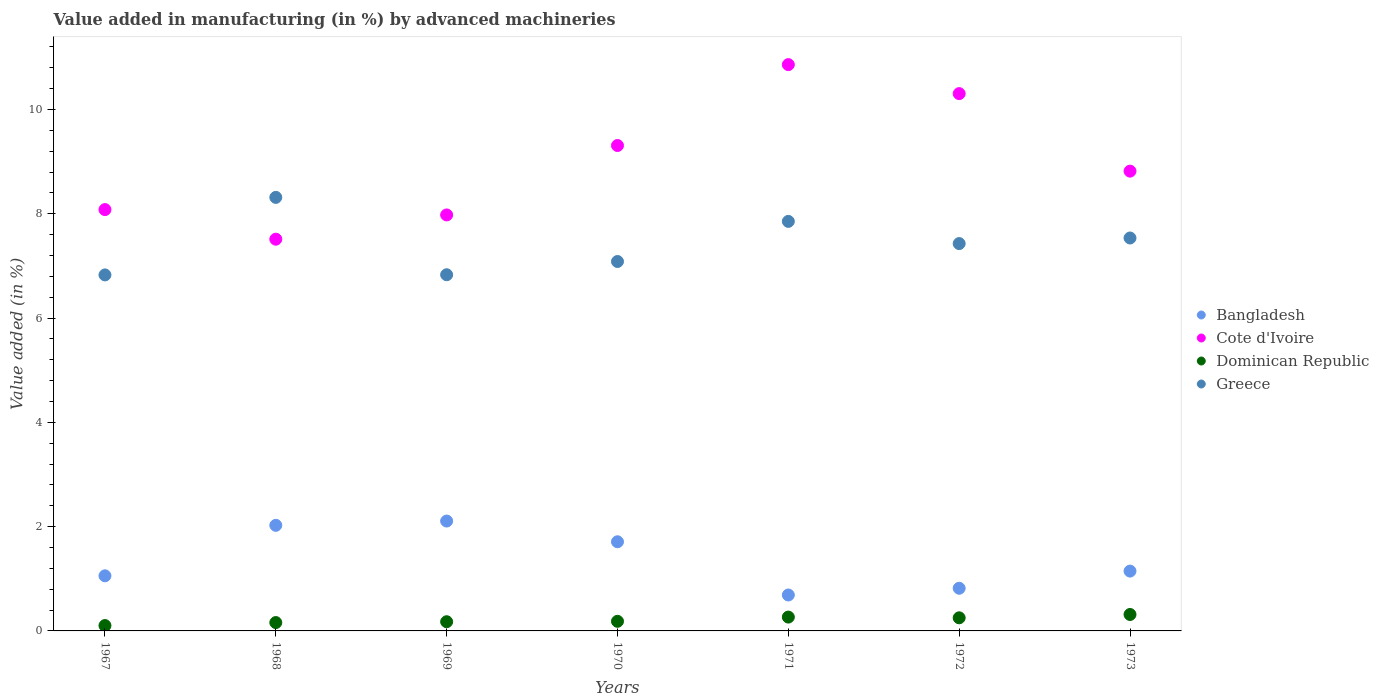Is the number of dotlines equal to the number of legend labels?
Your answer should be very brief. Yes. What is the percentage of value added in manufacturing by advanced machineries in Cote d'Ivoire in 1968?
Your answer should be compact. 7.51. Across all years, what is the maximum percentage of value added in manufacturing by advanced machineries in Cote d'Ivoire?
Give a very brief answer. 10.86. Across all years, what is the minimum percentage of value added in manufacturing by advanced machineries in Bangladesh?
Your response must be concise. 0.69. In which year was the percentage of value added in manufacturing by advanced machineries in Bangladesh maximum?
Give a very brief answer. 1969. In which year was the percentage of value added in manufacturing by advanced machineries in Greece minimum?
Offer a terse response. 1967. What is the total percentage of value added in manufacturing by advanced machineries in Bangladesh in the graph?
Provide a succinct answer. 9.55. What is the difference between the percentage of value added in manufacturing by advanced machineries in Bangladesh in 1967 and that in 1972?
Give a very brief answer. 0.24. What is the difference between the percentage of value added in manufacturing by advanced machineries in Bangladesh in 1969 and the percentage of value added in manufacturing by advanced machineries in Dominican Republic in 1970?
Provide a succinct answer. 1.92. What is the average percentage of value added in manufacturing by advanced machineries in Cote d'Ivoire per year?
Your answer should be very brief. 8.98. In the year 1969, what is the difference between the percentage of value added in manufacturing by advanced machineries in Cote d'Ivoire and percentage of value added in manufacturing by advanced machineries in Greece?
Give a very brief answer. 1.15. In how many years, is the percentage of value added in manufacturing by advanced machineries in Cote d'Ivoire greater than 7.2 %?
Ensure brevity in your answer.  7. What is the ratio of the percentage of value added in manufacturing by advanced machineries in Bangladesh in 1968 to that in 1969?
Give a very brief answer. 0.96. Is the percentage of value added in manufacturing by advanced machineries in Cote d'Ivoire in 1968 less than that in 1972?
Keep it short and to the point. Yes. What is the difference between the highest and the second highest percentage of value added in manufacturing by advanced machineries in Cote d'Ivoire?
Your answer should be very brief. 0.56. What is the difference between the highest and the lowest percentage of value added in manufacturing by advanced machineries in Greece?
Provide a short and direct response. 1.49. Is the sum of the percentage of value added in manufacturing by advanced machineries in Greece in 1972 and 1973 greater than the maximum percentage of value added in manufacturing by advanced machineries in Bangladesh across all years?
Give a very brief answer. Yes. Is it the case that in every year, the sum of the percentage of value added in manufacturing by advanced machineries in Cote d'Ivoire and percentage of value added in manufacturing by advanced machineries in Greece  is greater than the sum of percentage of value added in manufacturing by advanced machineries in Bangladesh and percentage of value added in manufacturing by advanced machineries in Dominican Republic?
Offer a very short reply. Yes. Is it the case that in every year, the sum of the percentage of value added in manufacturing by advanced machineries in Cote d'Ivoire and percentage of value added in manufacturing by advanced machineries in Greece  is greater than the percentage of value added in manufacturing by advanced machineries in Bangladesh?
Keep it short and to the point. Yes. Does the percentage of value added in manufacturing by advanced machineries in Cote d'Ivoire monotonically increase over the years?
Provide a short and direct response. No. Is the percentage of value added in manufacturing by advanced machineries in Greece strictly greater than the percentage of value added in manufacturing by advanced machineries in Bangladesh over the years?
Your answer should be very brief. Yes. Is the percentage of value added in manufacturing by advanced machineries in Greece strictly less than the percentage of value added in manufacturing by advanced machineries in Cote d'Ivoire over the years?
Provide a succinct answer. No. How many years are there in the graph?
Offer a very short reply. 7. What is the difference between two consecutive major ticks on the Y-axis?
Ensure brevity in your answer.  2. Does the graph contain any zero values?
Offer a very short reply. No. Does the graph contain grids?
Provide a succinct answer. No. What is the title of the graph?
Offer a very short reply. Value added in manufacturing (in %) by advanced machineries. What is the label or title of the X-axis?
Your answer should be compact. Years. What is the label or title of the Y-axis?
Your answer should be compact. Value added (in %). What is the Value added (in %) in Bangladesh in 1967?
Your response must be concise. 1.06. What is the Value added (in %) of Cote d'Ivoire in 1967?
Your response must be concise. 8.08. What is the Value added (in %) of Dominican Republic in 1967?
Offer a terse response. 0.1. What is the Value added (in %) of Greece in 1967?
Provide a short and direct response. 6.83. What is the Value added (in %) in Bangladesh in 1968?
Ensure brevity in your answer.  2.03. What is the Value added (in %) of Cote d'Ivoire in 1968?
Provide a succinct answer. 7.51. What is the Value added (in %) in Dominican Republic in 1968?
Your answer should be very brief. 0.16. What is the Value added (in %) in Greece in 1968?
Offer a terse response. 8.31. What is the Value added (in %) of Bangladesh in 1969?
Provide a short and direct response. 2.11. What is the Value added (in %) of Cote d'Ivoire in 1969?
Make the answer very short. 7.98. What is the Value added (in %) of Dominican Republic in 1969?
Offer a very short reply. 0.18. What is the Value added (in %) of Greece in 1969?
Make the answer very short. 6.83. What is the Value added (in %) in Bangladesh in 1970?
Your answer should be compact. 1.71. What is the Value added (in %) of Cote d'Ivoire in 1970?
Your answer should be compact. 9.31. What is the Value added (in %) of Dominican Republic in 1970?
Make the answer very short. 0.18. What is the Value added (in %) in Greece in 1970?
Keep it short and to the point. 7.08. What is the Value added (in %) of Bangladesh in 1971?
Ensure brevity in your answer.  0.69. What is the Value added (in %) in Cote d'Ivoire in 1971?
Your answer should be very brief. 10.86. What is the Value added (in %) in Dominican Republic in 1971?
Keep it short and to the point. 0.27. What is the Value added (in %) in Greece in 1971?
Keep it short and to the point. 7.85. What is the Value added (in %) in Bangladesh in 1972?
Provide a short and direct response. 0.82. What is the Value added (in %) in Cote d'Ivoire in 1972?
Your answer should be compact. 10.3. What is the Value added (in %) of Dominican Republic in 1972?
Your response must be concise. 0.25. What is the Value added (in %) of Greece in 1972?
Offer a terse response. 7.43. What is the Value added (in %) of Bangladesh in 1973?
Offer a terse response. 1.15. What is the Value added (in %) of Cote d'Ivoire in 1973?
Your answer should be very brief. 8.82. What is the Value added (in %) in Dominican Republic in 1973?
Make the answer very short. 0.32. What is the Value added (in %) in Greece in 1973?
Ensure brevity in your answer.  7.54. Across all years, what is the maximum Value added (in %) in Bangladesh?
Provide a succinct answer. 2.11. Across all years, what is the maximum Value added (in %) of Cote d'Ivoire?
Your answer should be very brief. 10.86. Across all years, what is the maximum Value added (in %) of Dominican Republic?
Provide a succinct answer. 0.32. Across all years, what is the maximum Value added (in %) in Greece?
Your answer should be compact. 8.31. Across all years, what is the minimum Value added (in %) of Bangladesh?
Keep it short and to the point. 0.69. Across all years, what is the minimum Value added (in %) of Cote d'Ivoire?
Ensure brevity in your answer.  7.51. Across all years, what is the minimum Value added (in %) in Dominican Republic?
Give a very brief answer. 0.1. Across all years, what is the minimum Value added (in %) of Greece?
Provide a short and direct response. 6.83. What is the total Value added (in %) of Bangladesh in the graph?
Give a very brief answer. 9.55. What is the total Value added (in %) in Cote d'Ivoire in the graph?
Give a very brief answer. 62.86. What is the total Value added (in %) in Dominican Republic in the graph?
Ensure brevity in your answer.  1.46. What is the total Value added (in %) of Greece in the graph?
Give a very brief answer. 51.88. What is the difference between the Value added (in %) in Bangladesh in 1967 and that in 1968?
Your answer should be very brief. -0.97. What is the difference between the Value added (in %) in Cote d'Ivoire in 1967 and that in 1968?
Give a very brief answer. 0.57. What is the difference between the Value added (in %) of Dominican Republic in 1967 and that in 1968?
Make the answer very short. -0.06. What is the difference between the Value added (in %) in Greece in 1967 and that in 1968?
Offer a terse response. -1.49. What is the difference between the Value added (in %) in Bangladesh in 1967 and that in 1969?
Provide a short and direct response. -1.05. What is the difference between the Value added (in %) of Cote d'Ivoire in 1967 and that in 1969?
Keep it short and to the point. 0.1. What is the difference between the Value added (in %) of Dominican Republic in 1967 and that in 1969?
Ensure brevity in your answer.  -0.07. What is the difference between the Value added (in %) in Greece in 1967 and that in 1969?
Give a very brief answer. -0. What is the difference between the Value added (in %) in Bangladesh in 1967 and that in 1970?
Make the answer very short. -0.65. What is the difference between the Value added (in %) in Cote d'Ivoire in 1967 and that in 1970?
Ensure brevity in your answer.  -1.23. What is the difference between the Value added (in %) of Dominican Republic in 1967 and that in 1970?
Your response must be concise. -0.08. What is the difference between the Value added (in %) in Greece in 1967 and that in 1970?
Give a very brief answer. -0.26. What is the difference between the Value added (in %) in Bangladesh in 1967 and that in 1971?
Your answer should be very brief. 0.37. What is the difference between the Value added (in %) in Cote d'Ivoire in 1967 and that in 1971?
Your answer should be compact. -2.78. What is the difference between the Value added (in %) in Dominican Republic in 1967 and that in 1971?
Provide a succinct answer. -0.16. What is the difference between the Value added (in %) in Greece in 1967 and that in 1971?
Your answer should be very brief. -1.03. What is the difference between the Value added (in %) in Bangladesh in 1967 and that in 1972?
Ensure brevity in your answer.  0.24. What is the difference between the Value added (in %) of Cote d'Ivoire in 1967 and that in 1972?
Your answer should be very brief. -2.22. What is the difference between the Value added (in %) of Dominican Republic in 1967 and that in 1972?
Offer a terse response. -0.15. What is the difference between the Value added (in %) of Greece in 1967 and that in 1972?
Give a very brief answer. -0.6. What is the difference between the Value added (in %) of Bangladesh in 1967 and that in 1973?
Your answer should be compact. -0.09. What is the difference between the Value added (in %) in Cote d'Ivoire in 1967 and that in 1973?
Provide a short and direct response. -0.74. What is the difference between the Value added (in %) in Dominican Republic in 1967 and that in 1973?
Provide a succinct answer. -0.21. What is the difference between the Value added (in %) in Greece in 1967 and that in 1973?
Give a very brief answer. -0.71. What is the difference between the Value added (in %) in Bangladesh in 1968 and that in 1969?
Provide a succinct answer. -0.08. What is the difference between the Value added (in %) of Cote d'Ivoire in 1968 and that in 1969?
Your response must be concise. -0.47. What is the difference between the Value added (in %) of Dominican Republic in 1968 and that in 1969?
Your response must be concise. -0.02. What is the difference between the Value added (in %) in Greece in 1968 and that in 1969?
Make the answer very short. 1.48. What is the difference between the Value added (in %) in Bangladesh in 1968 and that in 1970?
Provide a succinct answer. 0.32. What is the difference between the Value added (in %) of Cote d'Ivoire in 1968 and that in 1970?
Provide a succinct answer. -1.8. What is the difference between the Value added (in %) of Dominican Republic in 1968 and that in 1970?
Your response must be concise. -0.02. What is the difference between the Value added (in %) of Greece in 1968 and that in 1970?
Offer a very short reply. 1.23. What is the difference between the Value added (in %) in Bangladesh in 1968 and that in 1971?
Provide a succinct answer. 1.34. What is the difference between the Value added (in %) in Cote d'Ivoire in 1968 and that in 1971?
Give a very brief answer. -3.35. What is the difference between the Value added (in %) of Dominican Republic in 1968 and that in 1971?
Your answer should be very brief. -0.11. What is the difference between the Value added (in %) of Greece in 1968 and that in 1971?
Your response must be concise. 0.46. What is the difference between the Value added (in %) in Bangladesh in 1968 and that in 1972?
Ensure brevity in your answer.  1.21. What is the difference between the Value added (in %) of Cote d'Ivoire in 1968 and that in 1972?
Provide a short and direct response. -2.79. What is the difference between the Value added (in %) of Dominican Republic in 1968 and that in 1972?
Your answer should be very brief. -0.09. What is the difference between the Value added (in %) of Greece in 1968 and that in 1972?
Your answer should be very brief. 0.89. What is the difference between the Value added (in %) of Bangladesh in 1968 and that in 1973?
Your answer should be very brief. 0.88. What is the difference between the Value added (in %) of Cote d'Ivoire in 1968 and that in 1973?
Offer a terse response. -1.31. What is the difference between the Value added (in %) of Dominican Republic in 1968 and that in 1973?
Keep it short and to the point. -0.15. What is the difference between the Value added (in %) in Greece in 1968 and that in 1973?
Make the answer very short. 0.78. What is the difference between the Value added (in %) of Bangladesh in 1969 and that in 1970?
Provide a succinct answer. 0.4. What is the difference between the Value added (in %) of Cote d'Ivoire in 1969 and that in 1970?
Keep it short and to the point. -1.33. What is the difference between the Value added (in %) in Dominican Republic in 1969 and that in 1970?
Give a very brief answer. -0.01. What is the difference between the Value added (in %) in Greece in 1969 and that in 1970?
Provide a short and direct response. -0.25. What is the difference between the Value added (in %) in Bangladesh in 1969 and that in 1971?
Provide a short and direct response. 1.42. What is the difference between the Value added (in %) of Cote d'Ivoire in 1969 and that in 1971?
Your answer should be very brief. -2.88. What is the difference between the Value added (in %) in Dominican Republic in 1969 and that in 1971?
Give a very brief answer. -0.09. What is the difference between the Value added (in %) in Greece in 1969 and that in 1971?
Ensure brevity in your answer.  -1.02. What is the difference between the Value added (in %) in Bangladesh in 1969 and that in 1972?
Offer a very short reply. 1.29. What is the difference between the Value added (in %) of Cote d'Ivoire in 1969 and that in 1972?
Give a very brief answer. -2.33. What is the difference between the Value added (in %) of Dominican Republic in 1969 and that in 1972?
Your response must be concise. -0.07. What is the difference between the Value added (in %) of Greece in 1969 and that in 1972?
Your response must be concise. -0.6. What is the difference between the Value added (in %) in Bangladesh in 1969 and that in 1973?
Your answer should be compact. 0.96. What is the difference between the Value added (in %) of Cote d'Ivoire in 1969 and that in 1973?
Provide a short and direct response. -0.84. What is the difference between the Value added (in %) in Dominican Republic in 1969 and that in 1973?
Provide a succinct answer. -0.14. What is the difference between the Value added (in %) of Greece in 1969 and that in 1973?
Provide a short and direct response. -0.7. What is the difference between the Value added (in %) of Bangladesh in 1970 and that in 1971?
Offer a very short reply. 1.02. What is the difference between the Value added (in %) of Cote d'Ivoire in 1970 and that in 1971?
Your answer should be very brief. -1.55. What is the difference between the Value added (in %) in Dominican Republic in 1970 and that in 1971?
Offer a very short reply. -0.08. What is the difference between the Value added (in %) of Greece in 1970 and that in 1971?
Give a very brief answer. -0.77. What is the difference between the Value added (in %) in Bangladesh in 1970 and that in 1972?
Provide a short and direct response. 0.89. What is the difference between the Value added (in %) of Cote d'Ivoire in 1970 and that in 1972?
Provide a succinct answer. -1. What is the difference between the Value added (in %) of Dominican Republic in 1970 and that in 1972?
Your answer should be compact. -0.07. What is the difference between the Value added (in %) of Greece in 1970 and that in 1972?
Your response must be concise. -0.34. What is the difference between the Value added (in %) in Bangladesh in 1970 and that in 1973?
Offer a very short reply. 0.56. What is the difference between the Value added (in %) of Cote d'Ivoire in 1970 and that in 1973?
Offer a very short reply. 0.49. What is the difference between the Value added (in %) in Dominican Republic in 1970 and that in 1973?
Make the answer very short. -0.13. What is the difference between the Value added (in %) of Greece in 1970 and that in 1973?
Your answer should be very brief. -0.45. What is the difference between the Value added (in %) of Bangladesh in 1971 and that in 1972?
Ensure brevity in your answer.  -0.13. What is the difference between the Value added (in %) in Cote d'Ivoire in 1971 and that in 1972?
Ensure brevity in your answer.  0.56. What is the difference between the Value added (in %) of Dominican Republic in 1971 and that in 1972?
Give a very brief answer. 0.01. What is the difference between the Value added (in %) of Greece in 1971 and that in 1972?
Provide a succinct answer. 0.43. What is the difference between the Value added (in %) of Bangladesh in 1971 and that in 1973?
Provide a succinct answer. -0.46. What is the difference between the Value added (in %) of Cote d'Ivoire in 1971 and that in 1973?
Ensure brevity in your answer.  2.04. What is the difference between the Value added (in %) of Dominican Republic in 1971 and that in 1973?
Offer a very short reply. -0.05. What is the difference between the Value added (in %) of Greece in 1971 and that in 1973?
Make the answer very short. 0.32. What is the difference between the Value added (in %) in Bangladesh in 1972 and that in 1973?
Your response must be concise. -0.33. What is the difference between the Value added (in %) of Cote d'Ivoire in 1972 and that in 1973?
Your answer should be very brief. 1.49. What is the difference between the Value added (in %) in Dominican Republic in 1972 and that in 1973?
Offer a terse response. -0.06. What is the difference between the Value added (in %) in Greece in 1972 and that in 1973?
Give a very brief answer. -0.11. What is the difference between the Value added (in %) of Bangladesh in 1967 and the Value added (in %) of Cote d'Ivoire in 1968?
Your response must be concise. -6.46. What is the difference between the Value added (in %) in Bangladesh in 1967 and the Value added (in %) in Dominican Republic in 1968?
Offer a very short reply. 0.9. What is the difference between the Value added (in %) in Bangladesh in 1967 and the Value added (in %) in Greece in 1968?
Offer a very short reply. -7.26. What is the difference between the Value added (in %) of Cote d'Ivoire in 1967 and the Value added (in %) of Dominican Republic in 1968?
Your answer should be compact. 7.92. What is the difference between the Value added (in %) of Cote d'Ivoire in 1967 and the Value added (in %) of Greece in 1968?
Offer a terse response. -0.23. What is the difference between the Value added (in %) in Dominican Republic in 1967 and the Value added (in %) in Greece in 1968?
Give a very brief answer. -8.21. What is the difference between the Value added (in %) in Bangladesh in 1967 and the Value added (in %) in Cote d'Ivoire in 1969?
Provide a succinct answer. -6.92. What is the difference between the Value added (in %) of Bangladesh in 1967 and the Value added (in %) of Dominican Republic in 1969?
Provide a succinct answer. 0.88. What is the difference between the Value added (in %) of Bangladesh in 1967 and the Value added (in %) of Greece in 1969?
Your response must be concise. -5.77. What is the difference between the Value added (in %) of Cote d'Ivoire in 1967 and the Value added (in %) of Dominican Republic in 1969?
Make the answer very short. 7.9. What is the difference between the Value added (in %) of Cote d'Ivoire in 1967 and the Value added (in %) of Greece in 1969?
Your answer should be very brief. 1.25. What is the difference between the Value added (in %) of Dominican Republic in 1967 and the Value added (in %) of Greece in 1969?
Offer a terse response. -6.73. What is the difference between the Value added (in %) in Bangladesh in 1967 and the Value added (in %) in Cote d'Ivoire in 1970?
Keep it short and to the point. -8.25. What is the difference between the Value added (in %) in Bangladesh in 1967 and the Value added (in %) in Dominican Republic in 1970?
Offer a very short reply. 0.87. What is the difference between the Value added (in %) of Bangladesh in 1967 and the Value added (in %) of Greece in 1970?
Provide a succinct answer. -6.03. What is the difference between the Value added (in %) of Cote d'Ivoire in 1967 and the Value added (in %) of Dominican Republic in 1970?
Provide a short and direct response. 7.9. What is the difference between the Value added (in %) of Cote d'Ivoire in 1967 and the Value added (in %) of Greece in 1970?
Ensure brevity in your answer.  1. What is the difference between the Value added (in %) in Dominican Republic in 1967 and the Value added (in %) in Greece in 1970?
Your response must be concise. -6.98. What is the difference between the Value added (in %) in Bangladesh in 1967 and the Value added (in %) in Cote d'Ivoire in 1971?
Your response must be concise. -9.8. What is the difference between the Value added (in %) of Bangladesh in 1967 and the Value added (in %) of Dominican Republic in 1971?
Provide a succinct answer. 0.79. What is the difference between the Value added (in %) in Bangladesh in 1967 and the Value added (in %) in Greece in 1971?
Offer a very short reply. -6.8. What is the difference between the Value added (in %) of Cote d'Ivoire in 1967 and the Value added (in %) of Dominican Republic in 1971?
Ensure brevity in your answer.  7.82. What is the difference between the Value added (in %) in Cote d'Ivoire in 1967 and the Value added (in %) in Greece in 1971?
Give a very brief answer. 0.23. What is the difference between the Value added (in %) of Dominican Republic in 1967 and the Value added (in %) of Greece in 1971?
Provide a succinct answer. -7.75. What is the difference between the Value added (in %) of Bangladesh in 1967 and the Value added (in %) of Cote d'Ivoire in 1972?
Ensure brevity in your answer.  -9.25. What is the difference between the Value added (in %) in Bangladesh in 1967 and the Value added (in %) in Dominican Republic in 1972?
Provide a short and direct response. 0.81. What is the difference between the Value added (in %) of Bangladesh in 1967 and the Value added (in %) of Greece in 1972?
Your answer should be compact. -6.37. What is the difference between the Value added (in %) of Cote d'Ivoire in 1967 and the Value added (in %) of Dominican Republic in 1972?
Your response must be concise. 7.83. What is the difference between the Value added (in %) in Cote d'Ivoire in 1967 and the Value added (in %) in Greece in 1972?
Make the answer very short. 0.65. What is the difference between the Value added (in %) of Dominican Republic in 1967 and the Value added (in %) of Greece in 1972?
Ensure brevity in your answer.  -7.33. What is the difference between the Value added (in %) of Bangladesh in 1967 and the Value added (in %) of Cote d'Ivoire in 1973?
Ensure brevity in your answer.  -7.76. What is the difference between the Value added (in %) of Bangladesh in 1967 and the Value added (in %) of Dominican Republic in 1973?
Ensure brevity in your answer.  0.74. What is the difference between the Value added (in %) in Bangladesh in 1967 and the Value added (in %) in Greece in 1973?
Your answer should be very brief. -6.48. What is the difference between the Value added (in %) of Cote d'Ivoire in 1967 and the Value added (in %) of Dominican Republic in 1973?
Your answer should be very brief. 7.77. What is the difference between the Value added (in %) in Cote d'Ivoire in 1967 and the Value added (in %) in Greece in 1973?
Provide a short and direct response. 0.54. What is the difference between the Value added (in %) of Dominican Republic in 1967 and the Value added (in %) of Greece in 1973?
Ensure brevity in your answer.  -7.43. What is the difference between the Value added (in %) in Bangladesh in 1968 and the Value added (in %) in Cote d'Ivoire in 1969?
Offer a terse response. -5.95. What is the difference between the Value added (in %) of Bangladesh in 1968 and the Value added (in %) of Dominican Republic in 1969?
Your answer should be compact. 1.85. What is the difference between the Value added (in %) of Bangladesh in 1968 and the Value added (in %) of Greece in 1969?
Your answer should be compact. -4.81. What is the difference between the Value added (in %) of Cote d'Ivoire in 1968 and the Value added (in %) of Dominican Republic in 1969?
Offer a terse response. 7.34. What is the difference between the Value added (in %) in Cote d'Ivoire in 1968 and the Value added (in %) in Greece in 1969?
Offer a terse response. 0.68. What is the difference between the Value added (in %) of Dominican Republic in 1968 and the Value added (in %) of Greece in 1969?
Provide a short and direct response. -6.67. What is the difference between the Value added (in %) of Bangladesh in 1968 and the Value added (in %) of Cote d'Ivoire in 1970?
Ensure brevity in your answer.  -7.28. What is the difference between the Value added (in %) of Bangladesh in 1968 and the Value added (in %) of Dominican Republic in 1970?
Offer a terse response. 1.84. What is the difference between the Value added (in %) in Bangladesh in 1968 and the Value added (in %) in Greece in 1970?
Your answer should be very brief. -5.06. What is the difference between the Value added (in %) of Cote d'Ivoire in 1968 and the Value added (in %) of Dominican Republic in 1970?
Make the answer very short. 7.33. What is the difference between the Value added (in %) in Cote d'Ivoire in 1968 and the Value added (in %) in Greece in 1970?
Your answer should be very brief. 0.43. What is the difference between the Value added (in %) of Dominican Republic in 1968 and the Value added (in %) of Greece in 1970?
Offer a very short reply. -6.92. What is the difference between the Value added (in %) of Bangladesh in 1968 and the Value added (in %) of Cote d'Ivoire in 1971?
Make the answer very short. -8.84. What is the difference between the Value added (in %) in Bangladesh in 1968 and the Value added (in %) in Dominican Republic in 1971?
Give a very brief answer. 1.76. What is the difference between the Value added (in %) in Bangladesh in 1968 and the Value added (in %) in Greece in 1971?
Offer a terse response. -5.83. What is the difference between the Value added (in %) of Cote d'Ivoire in 1968 and the Value added (in %) of Dominican Republic in 1971?
Give a very brief answer. 7.25. What is the difference between the Value added (in %) of Cote d'Ivoire in 1968 and the Value added (in %) of Greece in 1971?
Give a very brief answer. -0.34. What is the difference between the Value added (in %) of Dominican Republic in 1968 and the Value added (in %) of Greece in 1971?
Give a very brief answer. -7.69. What is the difference between the Value added (in %) in Bangladesh in 1968 and the Value added (in %) in Cote d'Ivoire in 1972?
Your answer should be very brief. -8.28. What is the difference between the Value added (in %) of Bangladesh in 1968 and the Value added (in %) of Dominican Republic in 1972?
Provide a succinct answer. 1.77. What is the difference between the Value added (in %) in Bangladesh in 1968 and the Value added (in %) in Greece in 1972?
Your answer should be very brief. -5.4. What is the difference between the Value added (in %) of Cote d'Ivoire in 1968 and the Value added (in %) of Dominican Republic in 1972?
Offer a very short reply. 7.26. What is the difference between the Value added (in %) of Cote d'Ivoire in 1968 and the Value added (in %) of Greece in 1972?
Offer a very short reply. 0.08. What is the difference between the Value added (in %) of Dominican Republic in 1968 and the Value added (in %) of Greece in 1972?
Give a very brief answer. -7.27. What is the difference between the Value added (in %) of Bangladesh in 1968 and the Value added (in %) of Cote d'Ivoire in 1973?
Your answer should be very brief. -6.79. What is the difference between the Value added (in %) in Bangladesh in 1968 and the Value added (in %) in Dominican Republic in 1973?
Your answer should be very brief. 1.71. What is the difference between the Value added (in %) of Bangladesh in 1968 and the Value added (in %) of Greece in 1973?
Give a very brief answer. -5.51. What is the difference between the Value added (in %) of Cote d'Ivoire in 1968 and the Value added (in %) of Dominican Republic in 1973?
Your answer should be very brief. 7.2. What is the difference between the Value added (in %) in Cote d'Ivoire in 1968 and the Value added (in %) in Greece in 1973?
Your response must be concise. -0.02. What is the difference between the Value added (in %) in Dominican Republic in 1968 and the Value added (in %) in Greece in 1973?
Ensure brevity in your answer.  -7.38. What is the difference between the Value added (in %) of Bangladesh in 1969 and the Value added (in %) of Cote d'Ivoire in 1970?
Provide a short and direct response. -7.2. What is the difference between the Value added (in %) in Bangladesh in 1969 and the Value added (in %) in Dominican Republic in 1970?
Your answer should be compact. 1.92. What is the difference between the Value added (in %) of Bangladesh in 1969 and the Value added (in %) of Greece in 1970?
Keep it short and to the point. -4.98. What is the difference between the Value added (in %) in Cote d'Ivoire in 1969 and the Value added (in %) in Dominican Republic in 1970?
Ensure brevity in your answer.  7.79. What is the difference between the Value added (in %) in Cote d'Ivoire in 1969 and the Value added (in %) in Greece in 1970?
Your answer should be very brief. 0.89. What is the difference between the Value added (in %) of Dominican Republic in 1969 and the Value added (in %) of Greece in 1970?
Your answer should be compact. -6.91. What is the difference between the Value added (in %) in Bangladesh in 1969 and the Value added (in %) in Cote d'Ivoire in 1971?
Make the answer very short. -8.75. What is the difference between the Value added (in %) of Bangladesh in 1969 and the Value added (in %) of Dominican Republic in 1971?
Keep it short and to the point. 1.84. What is the difference between the Value added (in %) in Bangladesh in 1969 and the Value added (in %) in Greece in 1971?
Keep it short and to the point. -5.75. What is the difference between the Value added (in %) of Cote d'Ivoire in 1969 and the Value added (in %) of Dominican Republic in 1971?
Give a very brief answer. 7.71. What is the difference between the Value added (in %) of Cote d'Ivoire in 1969 and the Value added (in %) of Greece in 1971?
Provide a succinct answer. 0.12. What is the difference between the Value added (in %) in Dominican Republic in 1969 and the Value added (in %) in Greece in 1971?
Offer a terse response. -7.68. What is the difference between the Value added (in %) of Bangladesh in 1969 and the Value added (in %) of Cote d'Ivoire in 1972?
Ensure brevity in your answer.  -8.2. What is the difference between the Value added (in %) in Bangladesh in 1969 and the Value added (in %) in Dominican Republic in 1972?
Offer a terse response. 1.86. What is the difference between the Value added (in %) in Bangladesh in 1969 and the Value added (in %) in Greece in 1972?
Ensure brevity in your answer.  -5.32. What is the difference between the Value added (in %) in Cote d'Ivoire in 1969 and the Value added (in %) in Dominican Republic in 1972?
Give a very brief answer. 7.73. What is the difference between the Value added (in %) of Cote d'Ivoire in 1969 and the Value added (in %) of Greece in 1972?
Offer a very short reply. 0.55. What is the difference between the Value added (in %) of Dominican Republic in 1969 and the Value added (in %) of Greece in 1972?
Your answer should be very brief. -7.25. What is the difference between the Value added (in %) in Bangladesh in 1969 and the Value added (in %) in Cote d'Ivoire in 1973?
Give a very brief answer. -6.71. What is the difference between the Value added (in %) in Bangladesh in 1969 and the Value added (in %) in Dominican Republic in 1973?
Keep it short and to the point. 1.79. What is the difference between the Value added (in %) in Bangladesh in 1969 and the Value added (in %) in Greece in 1973?
Provide a succinct answer. -5.43. What is the difference between the Value added (in %) of Cote d'Ivoire in 1969 and the Value added (in %) of Dominican Republic in 1973?
Your answer should be very brief. 7.66. What is the difference between the Value added (in %) in Cote d'Ivoire in 1969 and the Value added (in %) in Greece in 1973?
Your answer should be compact. 0.44. What is the difference between the Value added (in %) in Dominican Republic in 1969 and the Value added (in %) in Greece in 1973?
Provide a succinct answer. -7.36. What is the difference between the Value added (in %) in Bangladesh in 1970 and the Value added (in %) in Cote d'Ivoire in 1971?
Give a very brief answer. -9.15. What is the difference between the Value added (in %) of Bangladesh in 1970 and the Value added (in %) of Dominican Republic in 1971?
Your answer should be very brief. 1.44. What is the difference between the Value added (in %) of Bangladesh in 1970 and the Value added (in %) of Greece in 1971?
Make the answer very short. -6.14. What is the difference between the Value added (in %) of Cote d'Ivoire in 1970 and the Value added (in %) of Dominican Republic in 1971?
Your answer should be very brief. 9.04. What is the difference between the Value added (in %) in Cote d'Ivoire in 1970 and the Value added (in %) in Greece in 1971?
Your answer should be very brief. 1.46. What is the difference between the Value added (in %) of Dominican Republic in 1970 and the Value added (in %) of Greece in 1971?
Keep it short and to the point. -7.67. What is the difference between the Value added (in %) of Bangladesh in 1970 and the Value added (in %) of Cote d'Ivoire in 1972?
Your answer should be compact. -8.59. What is the difference between the Value added (in %) in Bangladesh in 1970 and the Value added (in %) in Dominican Republic in 1972?
Provide a short and direct response. 1.46. What is the difference between the Value added (in %) in Bangladesh in 1970 and the Value added (in %) in Greece in 1972?
Your answer should be very brief. -5.72. What is the difference between the Value added (in %) of Cote d'Ivoire in 1970 and the Value added (in %) of Dominican Republic in 1972?
Provide a succinct answer. 9.06. What is the difference between the Value added (in %) in Cote d'Ivoire in 1970 and the Value added (in %) in Greece in 1972?
Make the answer very short. 1.88. What is the difference between the Value added (in %) of Dominican Republic in 1970 and the Value added (in %) of Greece in 1972?
Provide a succinct answer. -7.24. What is the difference between the Value added (in %) in Bangladesh in 1970 and the Value added (in %) in Cote d'Ivoire in 1973?
Make the answer very short. -7.11. What is the difference between the Value added (in %) of Bangladesh in 1970 and the Value added (in %) of Dominican Republic in 1973?
Provide a succinct answer. 1.39. What is the difference between the Value added (in %) of Bangladesh in 1970 and the Value added (in %) of Greece in 1973?
Your answer should be very brief. -5.83. What is the difference between the Value added (in %) of Cote d'Ivoire in 1970 and the Value added (in %) of Dominican Republic in 1973?
Keep it short and to the point. 8.99. What is the difference between the Value added (in %) of Cote d'Ivoire in 1970 and the Value added (in %) of Greece in 1973?
Your answer should be very brief. 1.77. What is the difference between the Value added (in %) in Dominican Republic in 1970 and the Value added (in %) in Greece in 1973?
Make the answer very short. -7.35. What is the difference between the Value added (in %) of Bangladesh in 1971 and the Value added (in %) of Cote d'Ivoire in 1972?
Ensure brevity in your answer.  -9.62. What is the difference between the Value added (in %) of Bangladesh in 1971 and the Value added (in %) of Dominican Republic in 1972?
Your answer should be compact. 0.44. What is the difference between the Value added (in %) in Bangladesh in 1971 and the Value added (in %) in Greece in 1972?
Provide a succinct answer. -6.74. What is the difference between the Value added (in %) of Cote d'Ivoire in 1971 and the Value added (in %) of Dominican Republic in 1972?
Ensure brevity in your answer.  10.61. What is the difference between the Value added (in %) of Cote d'Ivoire in 1971 and the Value added (in %) of Greece in 1972?
Offer a very short reply. 3.43. What is the difference between the Value added (in %) in Dominican Republic in 1971 and the Value added (in %) in Greece in 1972?
Keep it short and to the point. -7.16. What is the difference between the Value added (in %) of Bangladesh in 1971 and the Value added (in %) of Cote d'Ivoire in 1973?
Offer a very short reply. -8.13. What is the difference between the Value added (in %) of Bangladesh in 1971 and the Value added (in %) of Dominican Republic in 1973?
Ensure brevity in your answer.  0.37. What is the difference between the Value added (in %) of Bangladesh in 1971 and the Value added (in %) of Greece in 1973?
Ensure brevity in your answer.  -6.85. What is the difference between the Value added (in %) of Cote d'Ivoire in 1971 and the Value added (in %) of Dominican Republic in 1973?
Keep it short and to the point. 10.55. What is the difference between the Value added (in %) of Cote d'Ivoire in 1971 and the Value added (in %) of Greece in 1973?
Your answer should be compact. 3.33. What is the difference between the Value added (in %) of Dominican Republic in 1971 and the Value added (in %) of Greece in 1973?
Give a very brief answer. -7.27. What is the difference between the Value added (in %) of Bangladesh in 1972 and the Value added (in %) of Cote d'Ivoire in 1973?
Your response must be concise. -8. What is the difference between the Value added (in %) of Bangladesh in 1972 and the Value added (in %) of Dominican Republic in 1973?
Offer a very short reply. 0.5. What is the difference between the Value added (in %) in Bangladesh in 1972 and the Value added (in %) in Greece in 1973?
Your response must be concise. -6.72. What is the difference between the Value added (in %) in Cote d'Ivoire in 1972 and the Value added (in %) in Dominican Republic in 1973?
Provide a short and direct response. 9.99. What is the difference between the Value added (in %) in Cote d'Ivoire in 1972 and the Value added (in %) in Greece in 1973?
Keep it short and to the point. 2.77. What is the difference between the Value added (in %) in Dominican Republic in 1972 and the Value added (in %) in Greece in 1973?
Your answer should be compact. -7.28. What is the average Value added (in %) in Bangladesh per year?
Make the answer very short. 1.36. What is the average Value added (in %) in Cote d'Ivoire per year?
Make the answer very short. 8.98. What is the average Value added (in %) in Dominican Republic per year?
Your answer should be very brief. 0.21. What is the average Value added (in %) in Greece per year?
Ensure brevity in your answer.  7.41. In the year 1967, what is the difference between the Value added (in %) of Bangladesh and Value added (in %) of Cote d'Ivoire?
Provide a succinct answer. -7.02. In the year 1967, what is the difference between the Value added (in %) in Bangladesh and Value added (in %) in Dominican Republic?
Ensure brevity in your answer.  0.95. In the year 1967, what is the difference between the Value added (in %) of Bangladesh and Value added (in %) of Greece?
Your answer should be compact. -5.77. In the year 1967, what is the difference between the Value added (in %) in Cote d'Ivoire and Value added (in %) in Dominican Republic?
Make the answer very short. 7.98. In the year 1967, what is the difference between the Value added (in %) in Cote d'Ivoire and Value added (in %) in Greece?
Your answer should be compact. 1.25. In the year 1967, what is the difference between the Value added (in %) of Dominican Republic and Value added (in %) of Greece?
Provide a short and direct response. -6.72. In the year 1968, what is the difference between the Value added (in %) in Bangladesh and Value added (in %) in Cote d'Ivoire?
Make the answer very short. -5.49. In the year 1968, what is the difference between the Value added (in %) of Bangladesh and Value added (in %) of Dominican Republic?
Your answer should be very brief. 1.86. In the year 1968, what is the difference between the Value added (in %) of Bangladesh and Value added (in %) of Greece?
Provide a succinct answer. -6.29. In the year 1968, what is the difference between the Value added (in %) in Cote d'Ivoire and Value added (in %) in Dominican Republic?
Offer a very short reply. 7.35. In the year 1968, what is the difference between the Value added (in %) in Cote d'Ivoire and Value added (in %) in Greece?
Make the answer very short. -0.8. In the year 1968, what is the difference between the Value added (in %) of Dominican Republic and Value added (in %) of Greece?
Your response must be concise. -8.15. In the year 1969, what is the difference between the Value added (in %) in Bangladesh and Value added (in %) in Cote d'Ivoire?
Offer a very short reply. -5.87. In the year 1969, what is the difference between the Value added (in %) of Bangladesh and Value added (in %) of Dominican Republic?
Provide a short and direct response. 1.93. In the year 1969, what is the difference between the Value added (in %) in Bangladesh and Value added (in %) in Greece?
Your response must be concise. -4.72. In the year 1969, what is the difference between the Value added (in %) in Cote d'Ivoire and Value added (in %) in Dominican Republic?
Offer a terse response. 7.8. In the year 1969, what is the difference between the Value added (in %) in Cote d'Ivoire and Value added (in %) in Greece?
Your answer should be very brief. 1.15. In the year 1969, what is the difference between the Value added (in %) of Dominican Republic and Value added (in %) of Greece?
Provide a short and direct response. -6.65. In the year 1970, what is the difference between the Value added (in %) in Bangladesh and Value added (in %) in Cote d'Ivoire?
Make the answer very short. -7.6. In the year 1970, what is the difference between the Value added (in %) in Bangladesh and Value added (in %) in Dominican Republic?
Provide a short and direct response. 1.53. In the year 1970, what is the difference between the Value added (in %) of Bangladesh and Value added (in %) of Greece?
Keep it short and to the point. -5.38. In the year 1970, what is the difference between the Value added (in %) in Cote d'Ivoire and Value added (in %) in Dominican Republic?
Your answer should be very brief. 9.12. In the year 1970, what is the difference between the Value added (in %) in Cote d'Ivoire and Value added (in %) in Greece?
Ensure brevity in your answer.  2.22. In the year 1970, what is the difference between the Value added (in %) of Dominican Republic and Value added (in %) of Greece?
Keep it short and to the point. -6.9. In the year 1971, what is the difference between the Value added (in %) of Bangladesh and Value added (in %) of Cote d'Ivoire?
Provide a short and direct response. -10.17. In the year 1971, what is the difference between the Value added (in %) of Bangladesh and Value added (in %) of Dominican Republic?
Give a very brief answer. 0.42. In the year 1971, what is the difference between the Value added (in %) of Bangladesh and Value added (in %) of Greece?
Your answer should be very brief. -7.17. In the year 1971, what is the difference between the Value added (in %) in Cote d'Ivoire and Value added (in %) in Dominican Republic?
Provide a short and direct response. 10.6. In the year 1971, what is the difference between the Value added (in %) of Cote d'Ivoire and Value added (in %) of Greece?
Provide a short and direct response. 3.01. In the year 1971, what is the difference between the Value added (in %) of Dominican Republic and Value added (in %) of Greece?
Ensure brevity in your answer.  -7.59. In the year 1972, what is the difference between the Value added (in %) of Bangladesh and Value added (in %) of Cote d'Ivoire?
Provide a succinct answer. -9.49. In the year 1972, what is the difference between the Value added (in %) in Bangladesh and Value added (in %) in Dominican Republic?
Make the answer very short. 0.57. In the year 1972, what is the difference between the Value added (in %) in Bangladesh and Value added (in %) in Greece?
Give a very brief answer. -6.61. In the year 1972, what is the difference between the Value added (in %) of Cote d'Ivoire and Value added (in %) of Dominican Republic?
Keep it short and to the point. 10.05. In the year 1972, what is the difference between the Value added (in %) in Cote d'Ivoire and Value added (in %) in Greece?
Offer a very short reply. 2.88. In the year 1972, what is the difference between the Value added (in %) in Dominican Republic and Value added (in %) in Greece?
Keep it short and to the point. -7.18. In the year 1973, what is the difference between the Value added (in %) in Bangladesh and Value added (in %) in Cote d'Ivoire?
Offer a terse response. -7.67. In the year 1973, what is the difference between the Value added (in %) in Bangladesh and Value added (in %) in Dominican Republic?
Your response must be concise. 0.83. In the year 1973, what is the difference between the Value added (in %) in Bangladesh and Value added (in %) in Greece?
Give a very brief answer. -6.39. In the year 1973, what is the difference between the Value added (in %) in Cote d'Ivoire and Value added (in %) in Dominican Republic?
Your answer should be very brief. 8.5. In the year 1973, what is the difference between the Value added (in %) of Cote d'Ivoire and Value added (in %) of Greece?
Provide a short and direct response. 1.28. In the year 1973, what is the difference between the Value added (in %) of Dominican Republic and Value added (in %) of Greece?
Offer a terse response. -7.22. What is the ratio of the Value added (in %) in Bangladesh in 1967 to that in 1968?
Your answer should be compact. 0.52. What is the ratio of the Value added (in %) in Cote d'Ivoire in 1967 to that in 1968?
Make the answer very short. 1.08. What is the ratio of the Value added (in %) in Dominican Republic in 1967 to that in 1968?
Your response must be concise. 0.64. What is the ratio of the Value added (in %) of Greece in 1967 to that in 1968?
Provide a short and direct response. 0.82. What is the ratio of the Value added (in %) of Bangladesh in 1967 to that in 1969?
Ensure brevity in your answer.  0.5. What is the ratio of the Value added (in %) in Cote d'Ivoire in 1967 to that in 1969?
Keep it short and to the point. 1.01. What is the ratio of the Value added (in %) of Dominican Republic in 1967 to that in 1969?
Keep it short and to the point. 0.58. What is the ratio of the Value added (in %) of Bangladesh in 1967 to that in 1970?
Give a very brief answer. 0.62. What is the ratio of the Value added (in %) in Cote d'Ivoire in 1967 to that in 1970?
Offer a terse response. 0.87. What is the ratio of the Value added (in %) of Dominican Republic in 1967 to that in 1970?
Offer a very short reply. 0.56. What is the ratio of the Value added (in %) of Greece in 1967 to that in 1970?
Your answer should be compact. 0.96. What is the ratio of the Value added (in %) of Bangladesh in 1967 to that in 1971?
Offer a terse response. 1.53. What is the ratio of the Value added (in %) in Cote d'Ivoire in 1967 to that in 1971?
Your answer should be compact. 0.74. What is the ratio of the Value added (in %) of Dominican Republic in 1967 to that in 1971?
Give a very brief answer. 0.39. What is the ratio of the Value added (in %) in Greece in 1967 to that in 1971?
Keep it short and to the point. 0.87. What is the ratio of the Value added (in %) of Bangladesh in 1967 to that in 1972?
Offer a very short reply. 1.29. What is the ratio of the Value added (in %) of Cote d'Ivoire in 1967 to that in 1972?
Provide a succinct answer. 0.78. What is the ratio of the Value added (in %) in Dominican Republic in 1967 to that in 1972?
Give a very brief answer. 0.41. What is the ratio of the Value added (in %) in Greece in 1967 to that in 1972?
Provide a short and direct response. 0.92. What is the ratio of the Value added (in %) of Bangladesh in 1967 to that in 1973?
Provide a short and direct response. 0.92. What is the ratio of the Value added (in %) in Cote d'Ivoire in 1967 to that in 1973?
Ensure brevity in your answer.  0.92. What is the ratio of the Value added (in %) in Dominican Republic in 1967 to that in 1973?
Ensure brevity in your answer.  0.33. What is the ratio of the Value added (in %) of Greece in 1967 to that in 1973?
Your answer should be very brief. 0.91. What is the ratio of the Value added (in %) in Bangladesh in 1968 to that in 1969?
Ensure brevity in your answer.  0.96. What is the ratio of the Value added (in %) in Cote d'Ivoire in 1968 to that in 1969?
Offer a terse response. 0.94. What is the ratio of the Value added (in %) in Dominican Republic in 1968 to that in 1969?
Your answer should be very brief. 0.91. What is the ratio of the Value added (in %) in Greece in 1968 to that in 1969?
Provide a succinct answer. 1.22. What is the ratio of the Value added (in %) of Bangladesh in 1968 to that in 1970?
Provide a short and direct response. 1.18. What is the ratio of the Value added (in %) of Cote d'Ivoire in 1968 to that in 1970?
Ensure brevity in your answer.  0.81. What is the ratio of the Value added (in %) of Dominican Republic in 1968 to that in 1970?
Keep it short and to the point. 0.87. What is the ratio of the Value added (in %) in Greece in 1968 to that in 1970?
Your answer should be very brief. 1.17. What is the ratio of the Value added (in %) of Bangladesh in 1968 to that in 1971?
Your response must be concise. 2.94. What is the ratio of the Value added (in %) in Cote d'Ivoire in 1968 to that in 1971?
Make the answer very short. 0.69. What is the ratio of the Value added (in %) of Dominican Republic in 1968 to that in 1971?
Keep it short and to the point. 0.6. What is the ratio of the Value added (in %) of Greece in 1968 to that in 1971?
Your answer should be compact. 1.06. What is the ratio of the Value added (in %) of Bangladesh in 1968 to that in 1972?
Give a very brief answer. 2.48. What is the ratio of the Value added (in %) of Cote d'Ivoire in 1968 to that in 1972?
Offer a terse response. 0.73. What is the ratio of the Value added (in %) in Dominican Republic in 1968 to that in 1972?
Give a very brief answer. 0.64. What is the ratio of the Value added (in %) of Greece in 1968 to that in 1972?
Make the answer very short. 1.12. What is the ratio of the Value added (in %) in Bangladesh in 1968 to that in 1973?
Offer a very short reply. 1.77. What is the ratio of the Value added (in %) in Cote d'Ivoire in 1968 to that in 1973?
Make the answer very short. 0.85. What is the ratio of the Value added (in %) of Dominican Republic in 1968 to that in 1973?
Your answer should be very brief. 0.51. What is the ratio of the Value added (in %) in Greece in 1968 to that in 1973?
Your response must be concise. 1.1. What is the ratio of the Value added (in %) in Bangladesh in 1969 to that in 1970?
Your answer should be compact. 1.23. What is the ratio of the Value added (in %) in Cote d'Ivoire in 1969 to that in 1970?
Provide a succinct answer. 0.86. What is the ratio of the Value added (in %) of Dominican Republic in 1969 to that in 1970?
Provide a succinct answer. 0.96. What is the ratio of the Value added (in %) in Greece in 1969 to that in 1970?
Your answer should be compact. 0.96. What is the ratio of the Value added (in %) in Bangladesh in 1969 to that in 1971?
Offer a very short reply. 3.06. What is the ratio of the Value added (in %) in Cote d'Ivoire in 1969 to that in 1971?
Provide a succinct answer. 0.73. What is the ratio of the Value added (in %) in Dominican Republic in 1969 to that in 1971?
Make the answer very short. 0.66. What is the ratio of the Value added (in %) in Greece in 1969 to that in 1971?
Your answer should be very brief. 0.87. What is the ratio of the Value added (in %) of Bangladesh in 1969 to that in 1972?
Your answer should be compact. 2.58. What is the ratio of the Value added (in %) of Cote d'Ivoire in 1969 to that in 1972?
Make the answer very short. 0.77. What is the ratio of the Value added (in %) of Dominican Republic in 1969 to that in 1972?
Provide a short and direct response. 0.7. What is the ratio of the Value added (in %) of Greece in 1969 to that in 1972?
Make the answer very short. 0.92. What is the ratio of the Value added (in %) of Bangladesh in 1969 to that in 1973?
Your answer should be compact. 1.84. What is the ratio of the Value added (in %) in Cote d'Ivoire in 1969 to that in 1973?
Provide a short and direct response. 0.9. What is the ratio of the Value added (in %) in Dominican Republic in 1969 to that in 1973?
Offer a very short reply. 0.56. What is the ratio of the Value added (in %) in Greece in 1969 to that in 1973?
Your answer should be very brief. 0.91. What is the ratio of the Value added (in %) of Bangladesh in 1970 to that in 1971?
Your answer should be compact. 2.48. What is the ratio of the Value added (in %) of Cote d'Ivoire in 1970 to that in 1971?
Offer a very short reply. 0.86. What is the ratio of the Value added (in %) of Dominican Republic in 1970 to that in 1971?
Your answer should be compact. 0.7. What is the ratio of the Value added (in %) of Greece in 1970 to that in 1971?
Your answer should be compact. 0.9. What is the ratio of the Value added (in %) in Bangladesh in 1970 to that in 1972?
Your answer should be very brief. 2.09. What is the ratio of the Value added (in %) of Cote d'Ivoire in 1970 to that in 1972?
Give a very brief answer. 0.9. What is the ratio of the Value added (in %) of Dominican Republic in 1970 to that in 1972?
Keep it short and to the point. 0.73. What is the ratio of the Value added (in %) of Greece in 1970 to that in 1972?
Ensure brevity in your answer.  0.95. What is the ratio of the Value added (in %) in Bangladesh in 1970 to that in 1973?
Make the answer very short. 1.49. What is the ratio of the Value added (in %) in Cote d'Ivoire in 1970 to that in 1973?
Your answer should be compact. 1.06. What is the ratio of the Value added (in %) of Dominican Republic in 1970 to that in 1973?
Ensure brevity in your answer.  0.59. What is the ratio of the Value added (in %) of Greece in 1970 to that in 1973?
Offer a very short reply. 0.94. What is the ratio of the Value added (in %) in Bangladesh in 1971 to that in 1972?
Offer a very short reply. 0.84. What is the ratio of the Value added (in %) of Cote d'Ivoire in 1971 to that in 1972?
Give a very brief answer. 1.05. What is the ratio of the Value added (in %) in Dominican Republic in 1971 to that in 1972?
Ensure brevity in your answer.  1.06. What is the ratio of the Value added (in %) in Greece in 1971 to that in 1972?
Ensure brevity in your answer.  1.06. What is the ratio of the Value added (in %) of Bangladesh in 1971 to that in 1973?
Offer a very short reply. 0.6. What is the ratio of the Value added (in %) in Cote d'Ivoire in 1971 to that in 1973?
Make the answer very short. 1.23. What is the ratio of the Value added (in %) of Dominican Republic in 1971 to that in 1973?
Keep it short and to the point. 0.84. What is the ratio of the Value added (in %) in Greece in 1971 to that in 1973?
Your answer should be very brief. 1.04. What is the ratio of the Value added (in %) of Bangladesh in 1972 to that in 1973?
Your answer should be very brief. 0.71. What is the ratio of the Value added (in %) of Cote d'Ivoire in 1972 to that in 1973?
Ensure brevity in your answer.  1.17. What is the ratio of the Value added (in %) in Dominican Republic in 1972 to that in 1973?
Give a very brief answer. 0.8. What is the ratio of the Value added (in %) in Greece in 1972 to that in 1973?
Your response must be concise. 0.99. What is the difference between the highest and the second highest Value added (in %) of Bangladesh?
Provide a short and direct response. 0.08. What is the difference between the highest and the second highest Value added (in %) of Cote d'Ivoire?
Provide a short and direct response. 0.56. What is the difference between the highest and the second highest Value added (in %) in Dominican Republic?
Your answer should be very brief. 0.05. What is the difference between the highest and the second highest Value added (in %) of Greece?
Your answer should be very brief. 0.46. What is the difference between the highest and the lowest Value added (in %) in Bangladesh?
Your response must be concise. 1.42. What is the difference between the highest and the lowest Value added (in %) in Cote d'Ivoire?
Your response must be concise. 3.35. What is the difference between the highest and the lowest Value added (in %) of Dominican Republic?
Provide a succinct answer. 0.21. What is the difference between the highest and the lowest Value added (in %) in Greece?
Your response must be concise. 1.49. 